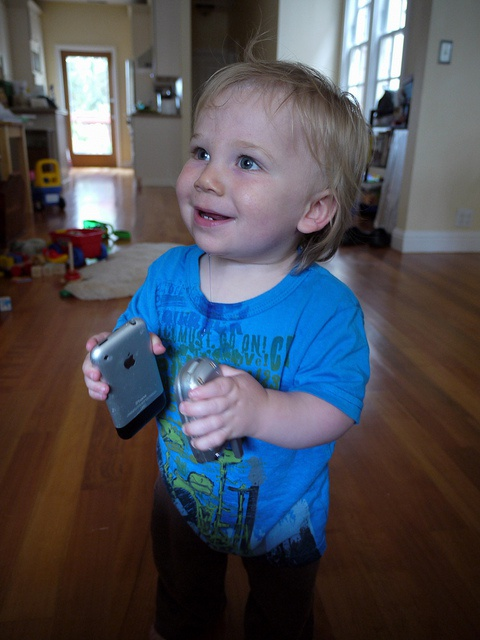Describe the objects in this image and their specific colors. I can see people in black, darkgray, blue, and gray tones, cell phone in black, blue, and gray tones, and cell phone in black, gray, and navy tones in this image. 